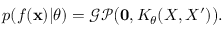<formula> <loc_0><loc_0><loc_500><loc_500>p ( f ( x ) | \theta ) = \mathcal { G P } \left ( 0 , K _ { \theta } ( X , X ^ { \prime } ) \right ) .</formula> 